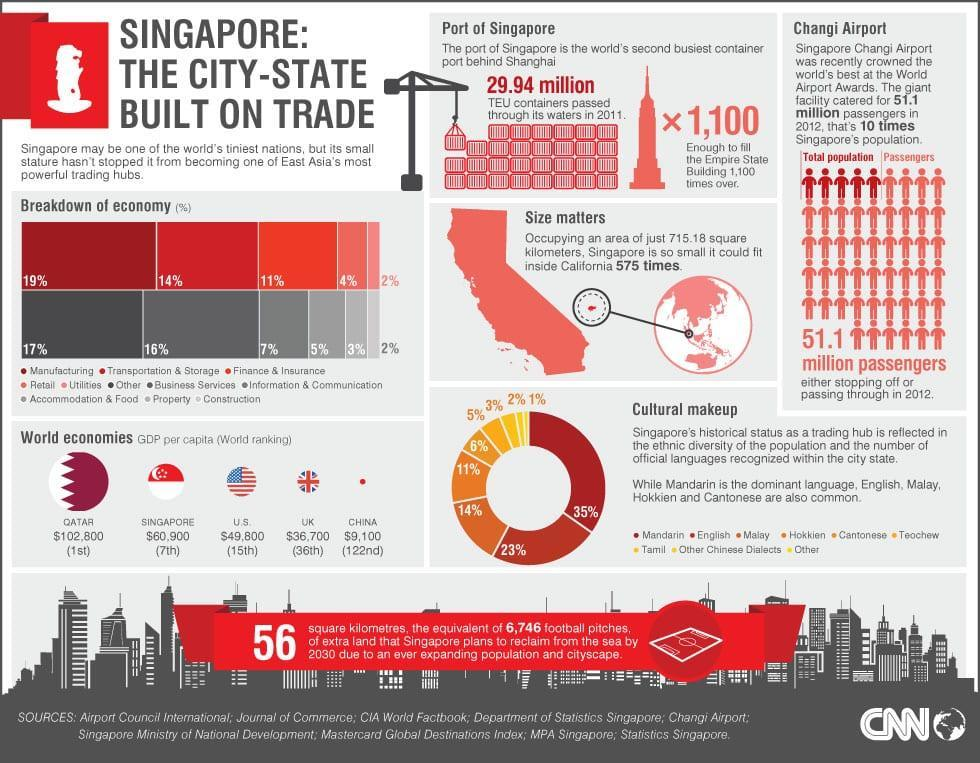What is the GDP of China?
Answer the question with a short phrase. $9,100 What is the rank of the UK in the world economy? 36th Which has the highest share in the languages of Singapore-English or Mandarin? Mandarin What percentage of utilities and retail together constitutes the GDP? 6% What percentage of manufacturing, transportation & storage together constitute the GDP? 33% What is the rank of China in the world economy? 122nd What percentage of property and construction together constitute the GDP? 5% What is the rank of the U.S in the world economy? 15th What is the rank of Singapore in the world economy? 7th What is the GDP of the U.S? $49,800 